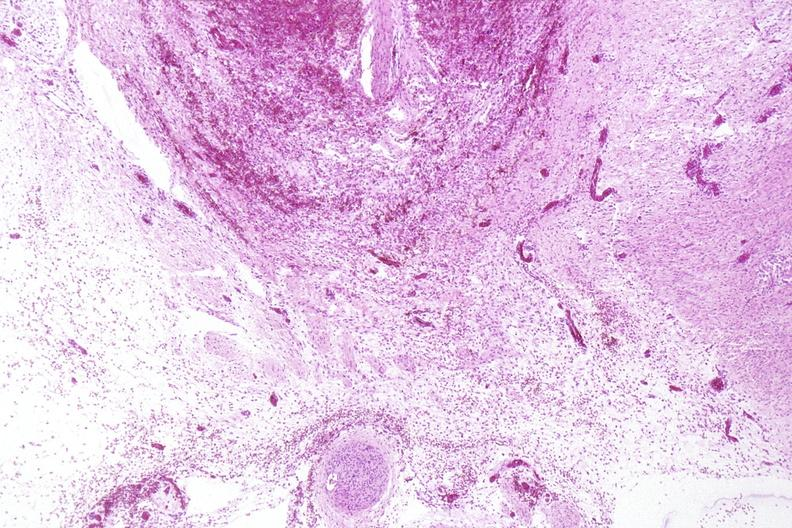does cut show neural tube defect, meningomyelocele?
Answer the question using a single word or phrase. No 